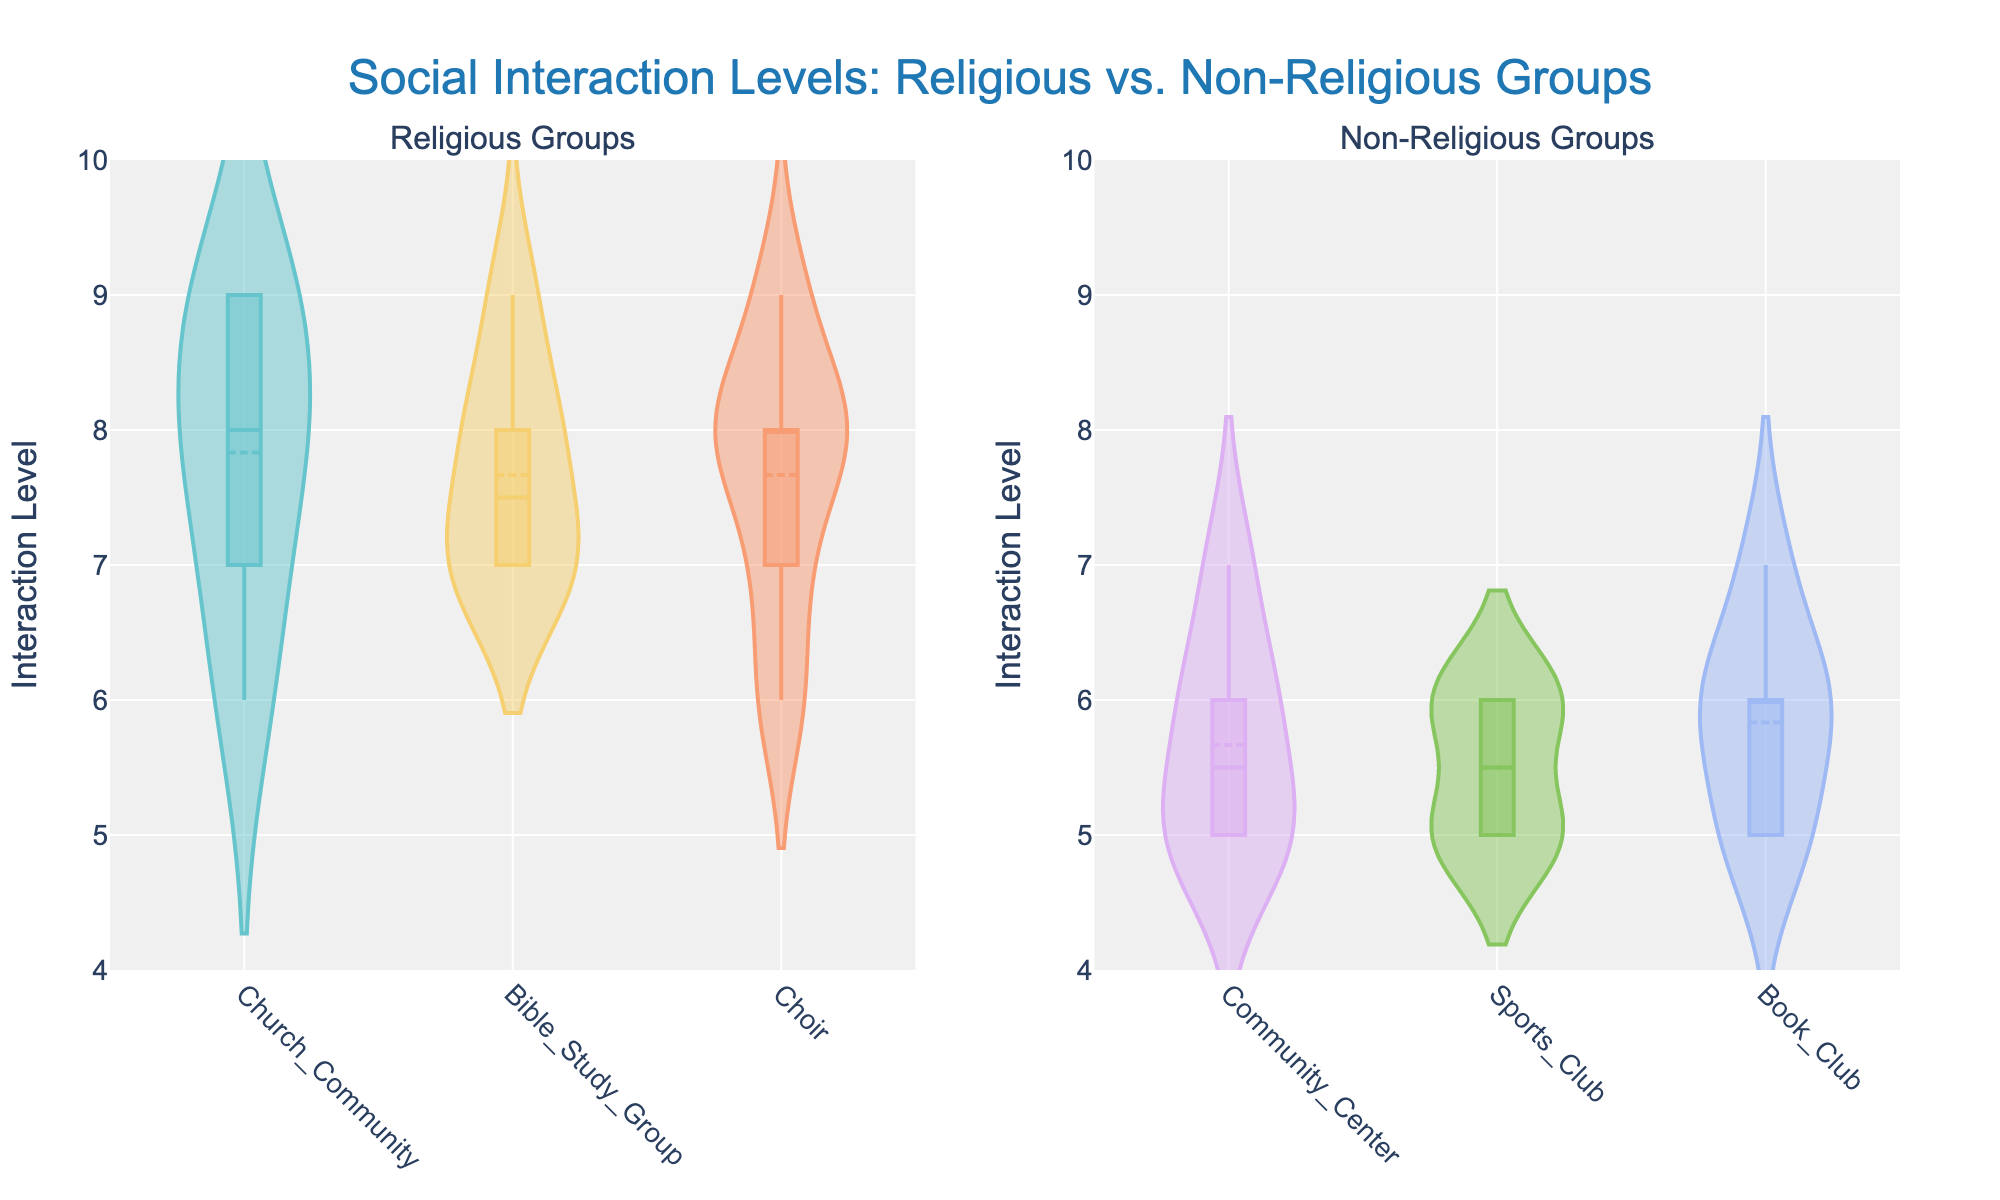what is the highest interaction level in the religious groups? The highest interaction level in the religious groups can be identified by looking at the upper extremities of the violin plots for Church Community, Bible Study Group, and Choir. The maximum value for each of these groups is 9, which appears to be the highest shared among them.
Answer: 9 How many social groups are represented in each subplot? By examining the figure's layout, the left subplot titled "Religious Groups" displays three groups (Church Community, Bible Study Group, and Choir), whereas the right subplot titled "Non-Religious Groups" also displays three groups (Community Center, Sports Club, and Book Club).
Answer: 3 and 3 Which non-religious group has the lowest interaction level? The lowest interaction level for the non-religious groups can be found by looking at the bottom range of each group's violin plot. For Community Center, it's 5, for Sports Club, it's 5, and for Book Club, it's also 5. They all share the same minimum value of 5.
Answer: They all share the same minimum value of 5 How do the average interaction levels of Choir and Sports Club compare? To compare the average interaction levels, observe the mean lines within the violin plots. For Choir (a religious group) and Sports Club (a non-religious group), the average lines should be examined. Choir's average appears around 7.5-8, while Sports Club's is approximately around 5.5-6.
Answer: Choir's average is higher What is the median interaction level for the Community Center group? For the Community Center group in the non-religious subplot, we locate the median line (middle line in the box plot within the violin). This line appears at interaction level 6.
Answer: 6 Is there a significant difference between the highest interaction levels of religious and non-religious groups? Both the subplots for religious and non-religious groups show maximum interaction levels of 9. This indicates no significant difference in the highest interaction levels between the two categories.
Answer: No Which group has the widest range of interaction levels within religious groups? The range of a violin plot is the difference between the highest and lowest values. For Church Community, the range is from 6 to 9 (3 units), for Bible Study Group from 7 to 9 (2 units), and for Choir from 6 to 9 (3 units). Both Church Community and Choir have the widest range of 3 units.
Answer: Church Community and Choir What's the most frequent interaction level in the Book Club? The thickest part of the Book Club's violin plot within the non-religious groups indicates the most frequent levels. The plot appears thickest around the interaction level 6.
Answer: 6 Which group in religious groups has the most uniform interaction level distribution? Uniformity can be observed by the shape of the violin plots. A more uniform plot appears balanced with no pronounced tails. Bible Study Group’s plot has a more even and consistent spread compared to the others showing tighter peaks.
Answer: Bible Study Group 